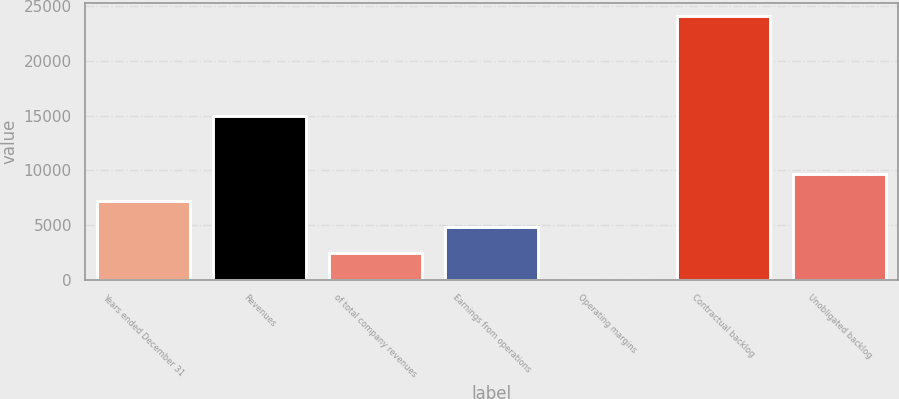Convert chart. <chart><loc_0><loc_0><loc_500><loc_500><bar_chart><fcel>Years ended December 31<fcel>Revenues<fcel>of total company revenues<fcel>Earnings from operations<fcel>Operating margins<fcel>Contractual backlog<fcel>Unobligated backlog<nl><fcel>7232.64<fcel>14947<fcel>2417.68<fcel>4825.16<fcel>10.2<fcel>24085<fcel>9640.12<nl></chart> 